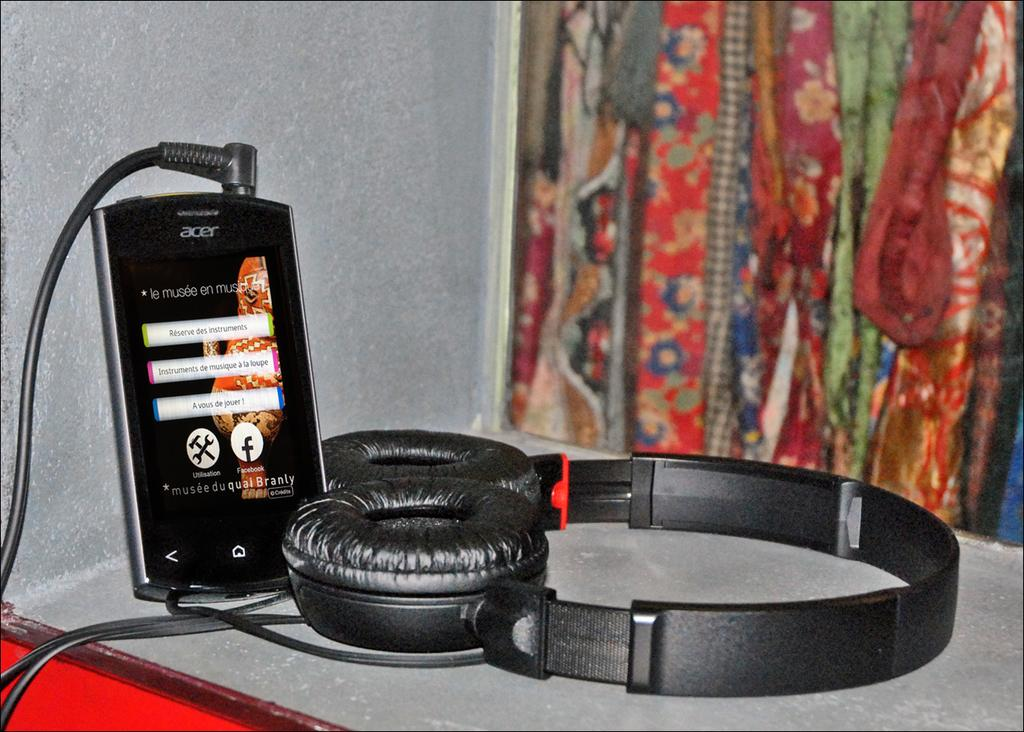<image>
Summarize the visual content of the image. a logo is on a phone with the letter F on it 